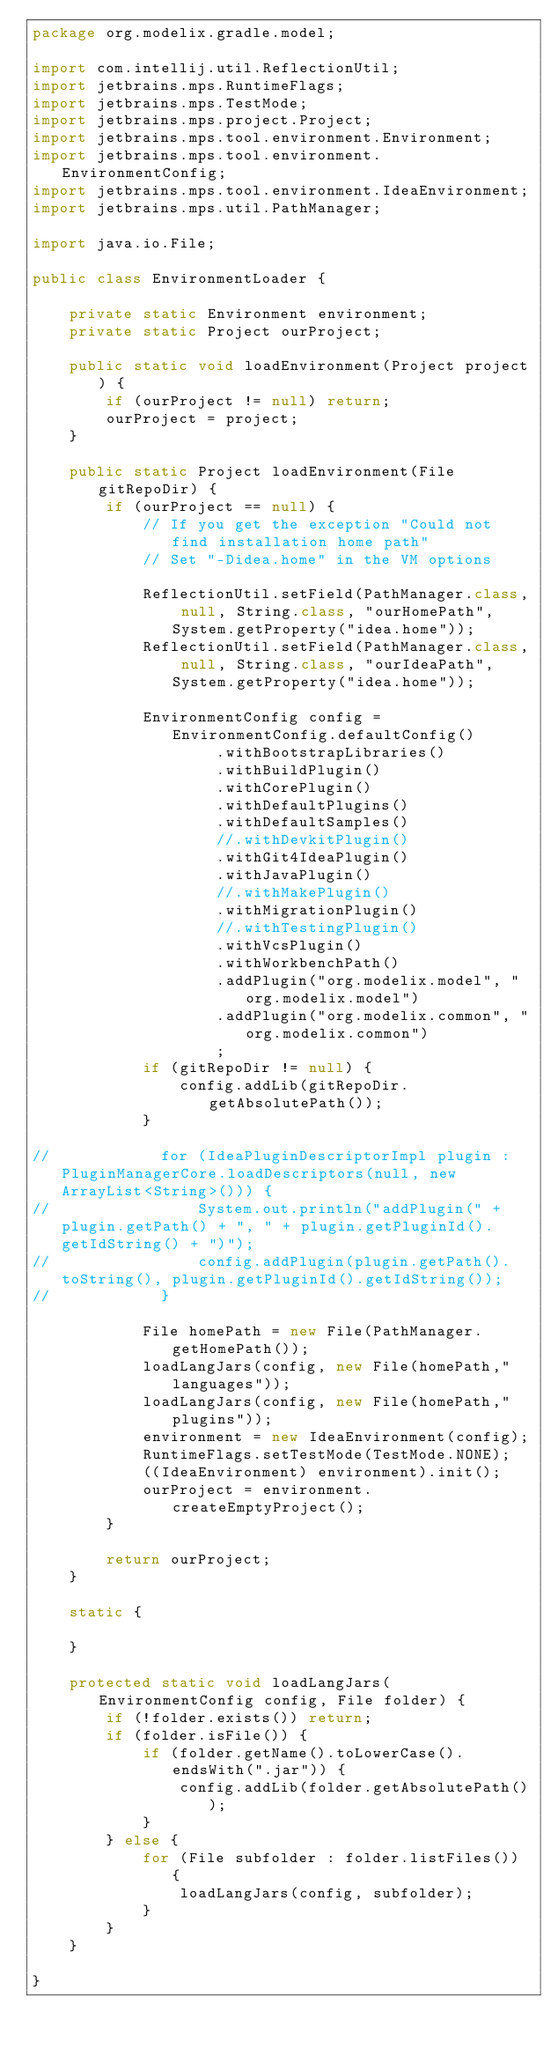<code> <loc_0><loc_0><loc_500><loc_500><_Java_>package org.modelix.gradle.model;

import com.intellij.util.ReflectionUtil;
import jetbrains.mps.RuntimeFlags;
import jetbrains.mps.TestMode;
import jetbrains.mps.project.Project;
import jetbrains.mps.tool.environment.Environment;
import jetbrains.mps.tool.environment.EnvironmentConfig;
import jetbrains.mps.tool.environment.IdeaEnvironment;
import jetbrains.mps.util.PathManager;

import java.io.File;

public class EnvironmentLoader {

    private static Environment environment;
    private static Project ourProject;

    public static void loadEnvironment(Project project) {
        if (ourProject != null) return;
        ourProject = project;
    }

    public static Project loadEnvironment(File gitRepoDir) {
        if (ourProject == null) {
            // If you get the exception "Could not find installation home path"
            // Set "-Didea.home" in the VM options

            ReflectionUtil.setField(PathManager.class, null, String.class, "ourHomePath", System.getProperty("idea.home"));
            ReflectionUtil.setField(PathManager.class, null, String.class, "ourIdeaPath", System.getProperty("idea.home"));

            EnvironmentConfig config = EnvironmentConfig.defaultConfig()
                    .withBootstrapLibraries()
                    .withBuildPlugin()
                    .withCorePlugin()
                    .withDefaultPlugins()
                    .withDefaultSamples()
                    //.withDevkitPlugin()
                    .withGit4IdeaPlugin()
                    .withJavaPlugin()
                    //.withMakePlugin()
                    .withMigrationPlugin()
                    //.withTestingPlugin()
                    .withVcsPlugin()
                    .withWorkbenchPath()
                    .addPlugin("org.modelix.model", "org.modelix.model")
                    .addPlugin("org.modelix.common", "org.modelix.common")
                    ;
            if (gitRepoDir != null) {
                config.addLib(gitRepoDir.getAbsolutePath());
            }

//            for (IdeaPluginDescriptorImpl plugin : PluginManagerCore.loadDescriptors(null, new ArrayList<String>())) {
//                System.out.println("addPlugin(" + plugin.getPath() + ", " + plugin.getPluginId().getIdString() + ")");
//                config.addPlugin(plugin.getPath().toString(), plugin.getPluginId().getIdString());
//            }

            File homePath = new File(PathManager.getHomePath());
            loadLangJars(config, new File(homePath,"languages"));
            loadLangJars(config, new File(homePath,"plugins"));
            environment = new IdeaEnvironment(config);
            RuntimeFlags.setTestMode(TestMode.NONE);
            ((IdeaEnvironment) environment).init();
            ourProject = environment.createEmptyProject();
        }

        return ourProject;
    }

    static {

    }

    protected static void loadLangJars(EnvironmentConfig config, File folder) {
        if (!folder.exists()) return;
        if (folder.isFile()) {
            if (folder.getName().toLowerCase().endsWith(".jar")) {
                config.addLib(folder.getAbsolutePath());
            }
        } else {
            for (File subfolder : folder.listFiles()) {
                loadLangJars(config, subfolder);
            }
        }
    }

}
</code> 